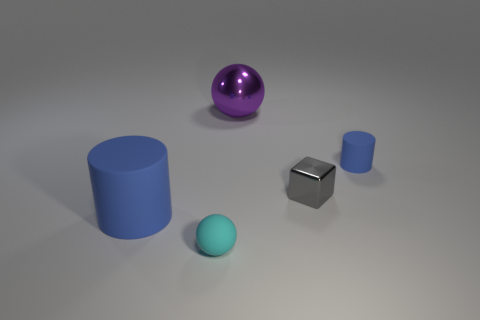What shape is the tiny blue object? The tiny blue object in the image appears to have a cylindrical shape, characterized by its two circular faces connected by a curved surface. 